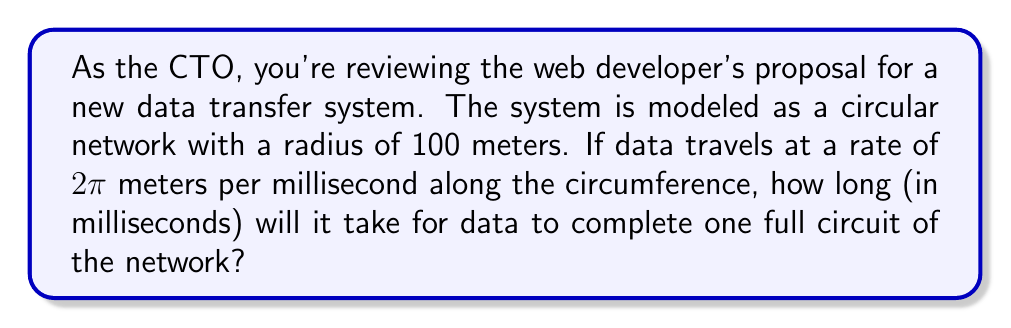Could you help me with this problem? Let's approach this step-by-step:

1) First, we need to calculate the circumference of the circular network. The formula for circumference is:

   $$C = 2\pi r$$

   where $C$ is the circumference and $r$ is the radius.

2) Given that the radius is 100 meters, we can calculate:

   $$C = 2\pi (100) = 200\pi \text{ meters}$$

3) Now, we know that data travels at a rate of $2\pi$ meters per millisecond. To find the time taken, we can use the formula:

   $$\text{Time} = \frac{\text{Distance}}{\text{Speed}}$$

4) Substituting our values:

   $$\text{Time} = \frac{200\pi}{2\pi} = 100 \text{ milliseconds}$$

5) Therefore, it will take 100 milliseconds for data to complete one full circuit of the network.
Answer: 100 ms 